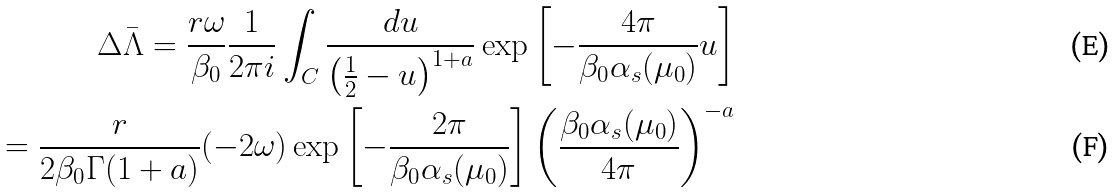Convert formula to latex. <formula><loc_0><loc_0><loc_500><loc_500>\Delta \bar { \Lambda } = \frac { r \omega } { \beta _ { 0 } } \frac { 1 } { 2 \pi i } \int _ { C } \frac { d u } { \left ( \frac { 1 } { 2 } - u \right ) ^ { 1 + a } } \exp \left [ - \frac { 4 \pi } { \beta _ { 0 } \alpha _ { s } ( \mu _ { 0 } ) } u \right ] \\ = \frac { r } { 2 \beta _ { 0 } \Gamma ( 1 + a ) } ( - 2 \omega ) \exp \left [ - \frac { 2 \pi } { \beta _ { 0 } \alpha _ { s } ( \mu _ { 0 } ) } \right ] \left ( \frac { \beta _ { 0 } \alpha _ { s } ( \mu _ { 0 } ) } { 4 \pi } \right ) ^ { - a }</formula> 